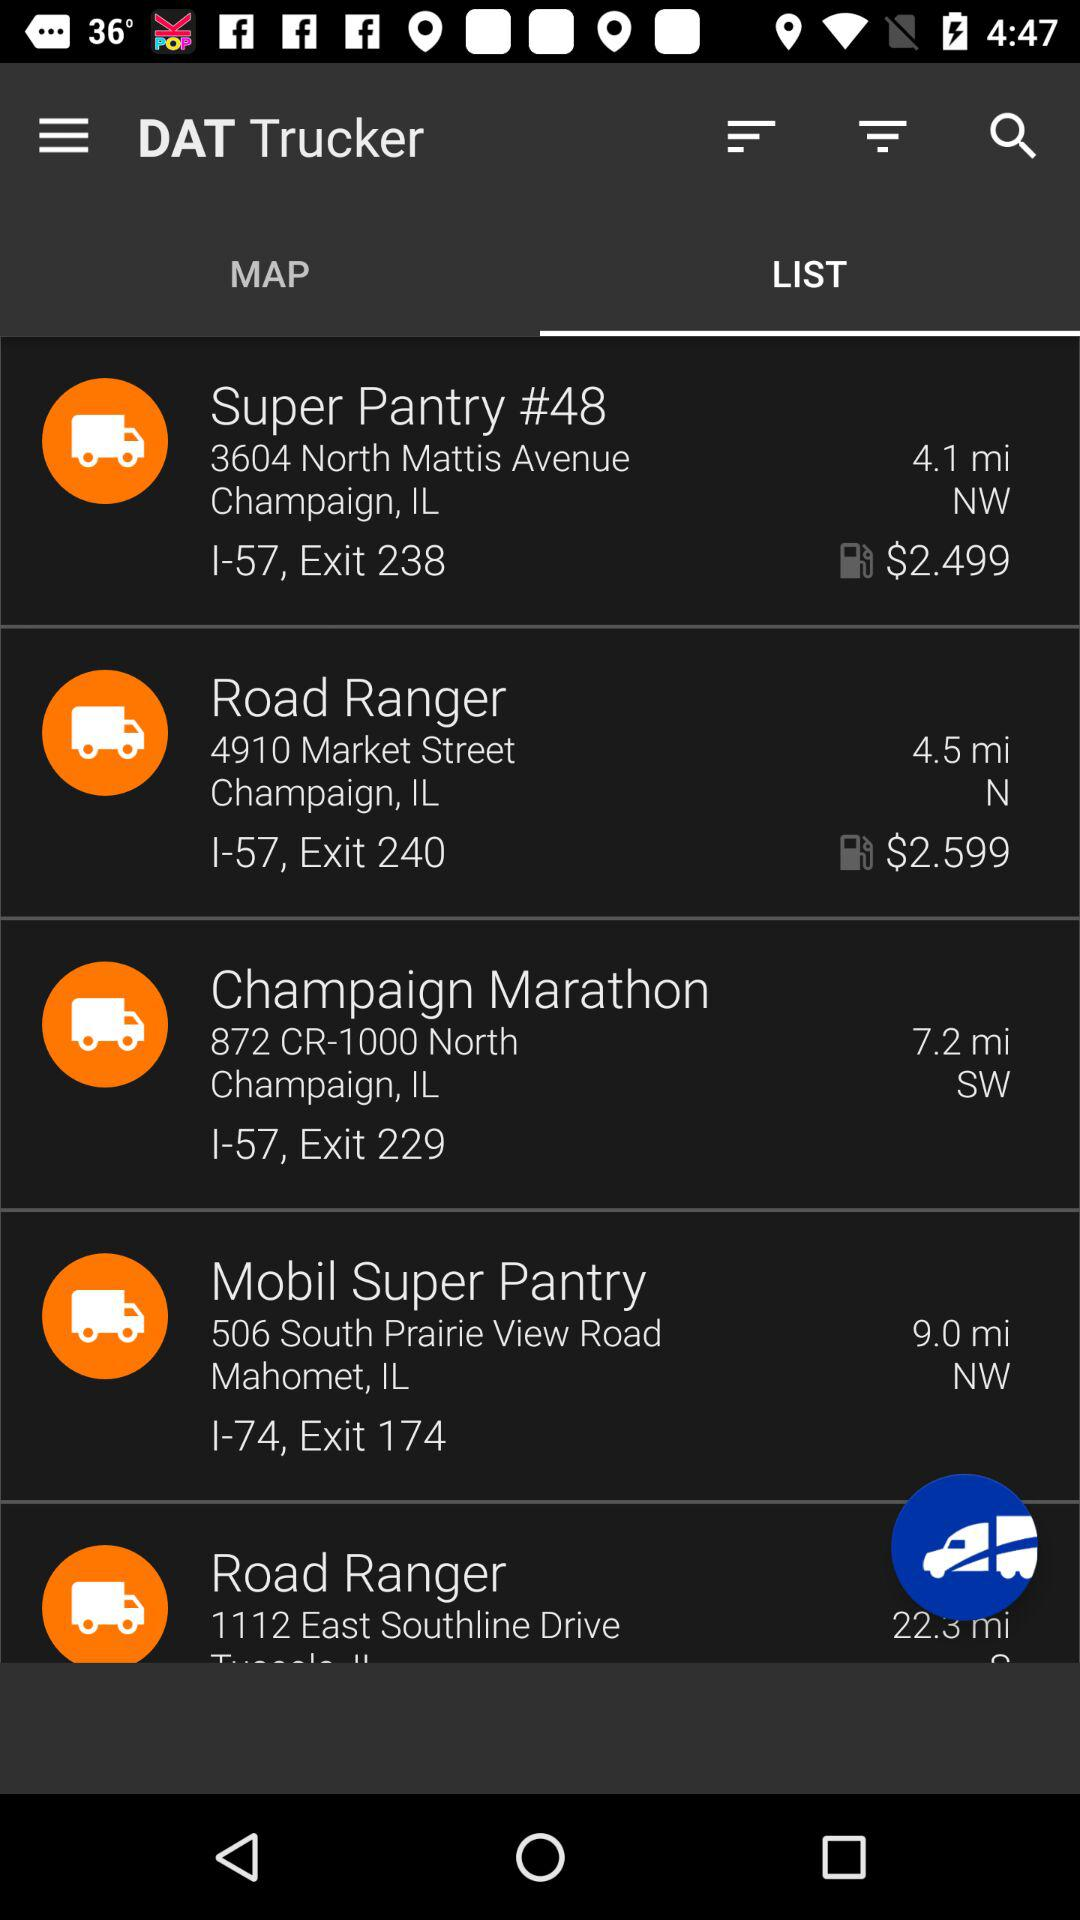What is the application name? The application name is "DAT Trucker". 